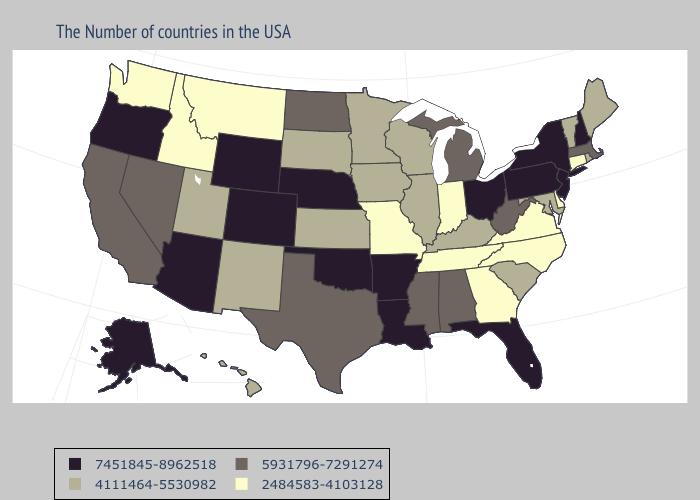Does the map have missing data?
Be succinct. No. Which states hav the highest value in the MidWest?
Write a very short answer. Ohio, Nebraska. Does Oklahoma have a higher value than Louisiana?
Write a very short answer. No. Name the states that have a value in the range 5931796-7291274?
Give a very brief answer. Massachusetts, West Virginia, Michigan, Alabama, Mississippi, Texas, North Dakota, Nevada, California. Does Idaho have the lowest value in the West?
Keep it brief. Yes. What is the highest value in the South ?
Give a very brief answer. 7451845-8962518. What is the highest value in the West ?
Answer briefly. 7451845-8962518. Which states hav the highest value in the MidWest?
Be succinct. Ohio, Nebraska. Does Florida have the same value as Arkansas?
Concise answer only. Yes. What is the value of Washington?
Be succinct. 2484583-4103128. What is the highest value in the USA?
Short answer required. 7451845-8962518. What is the lowest value in the USA?
Be succinct. 2484583-4103128. Among the states that border Iowa , does South Dakota have the lowest value?
Give a very brief answer. No. How many symbols are there in the legend?
Give a very brief answer. 4. 